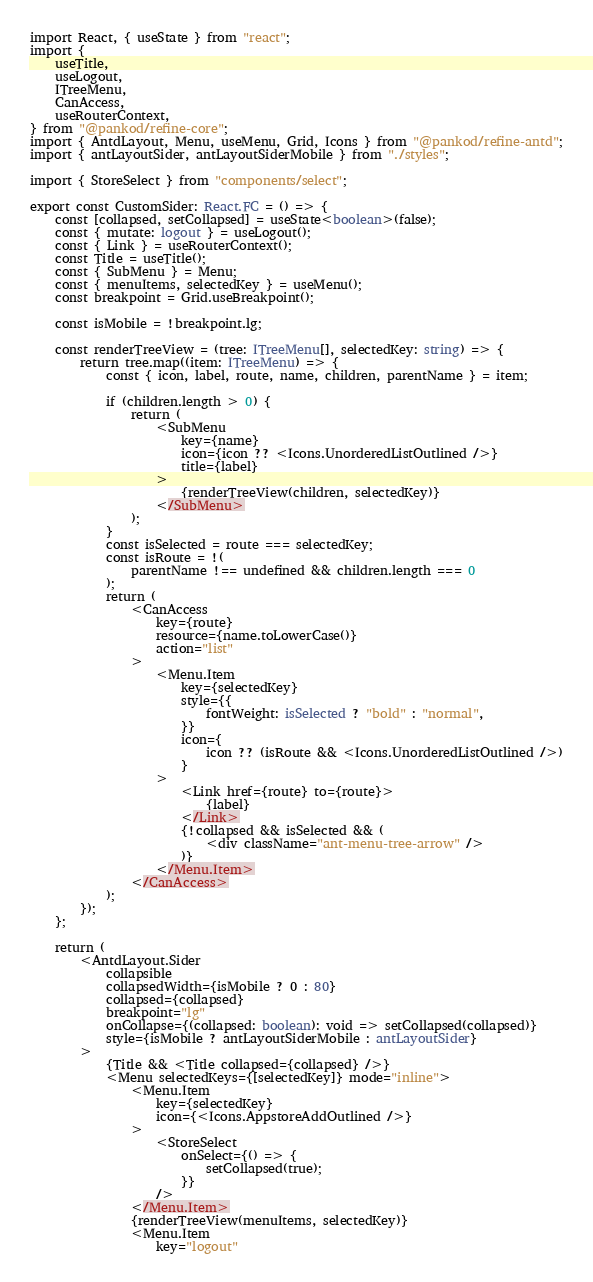Convert code to text. <code><loc_0><loc_0><loc_500><loc_500><_TypeScript_>import React, { useState } from "react";
import {
    useTitle,
    useLogout,
    ITreeMenu,
    CanAccess,
    useRouterContext,
} from "@pankod/refine-core";
import { AntdLayout, Menu, useMenu, Grid, Icons } from "@pankod/refine-antd";
import { antLayoutSider, antLayoutSiderMobile } from "./styles";

import { StoreSelect } from "components/select";

export const CustomSider: React.FC = () => {
    const [collapsed, setCollapsed] = useState<boolean>(false);
    const { mutate: logout } = useLogout();
    const { Link } = useRouterContext();
    const Title = useTitle();
    const { SubMenu } = Menu;
    const { menuItems, selectedKey } = useMenu();
    const breakpoint = Grid.useBreakpoint();

    const isMobile = !breakpoint.lg;

    const renderTreeView = (tree: ITreeMenu[], selectedKey: string) => {
        return tree.map((item: ITreeMenu) => {
            const { icon, label, route, name, children, parentName } = item;

            if (children.length > 0) {
                return (
                    <SubMenu
                        key={name}
                        icon={icon ?? <Icons.UnorderedListOutlined />}
                        title={label}
                    >
                        {renderTreeView(children, selectedKey)}
                    </SubMenu>
                );
            }
            const isSelected = route === selectedKey;
            const isRoute = !(
                parentName !== undefined && children.length === 0
            );
            return (
                <CanAccess
                    key={route}
                    resource={name.toLowerCase()}
                    action="list"
                >
                    <Menu.Item
                        key={selectedKey}
                        style={{
                            fontWeight: isSelected ? "bold" : "normal",
                        }}
                        icon={
                            icon ?? (isRoute && <Icons.UnorderedListOutlined />)
                        }
                    >
                        <Link href={route} to={route}>
                            {label}
                        </Link>
                        {!collapsed && isSelected && (
                            <div className="ant-menu-tree-arrow" />
                        )}
                    </Menu.Item>
                </CanAccess>
            );
        });
    };

    return (
        <AntdLayout.Sider
            collapsible
            collapsedWidth={isMobile ? 0 : 80}
            collapsed={collapsed}
            breakpoint="lg"
            onCollapse={(collapsed: boolean): void => setCollapsed(collapsed)}
            style={isMobile ? antLayoutSiderMobile : antLayoutSider}
        >
            {Title && <Title collapsed={collapsed} />}
            <Menu selectedKeys={[selectedKey]} mode="inline">
                <Menu.Item
                    key={selectedKey}
                    icon={<Icons.AppstoreAddOutlined />}
                >
                    <StoreSelect
                        onSelect={() => {
                            setCollapsed(true);
                        }}
                    />
                </Menu.Item>
                {renderTreeView(menuItems, selectedKey)}
                <Menu.Item
                    key="logout"</code> 